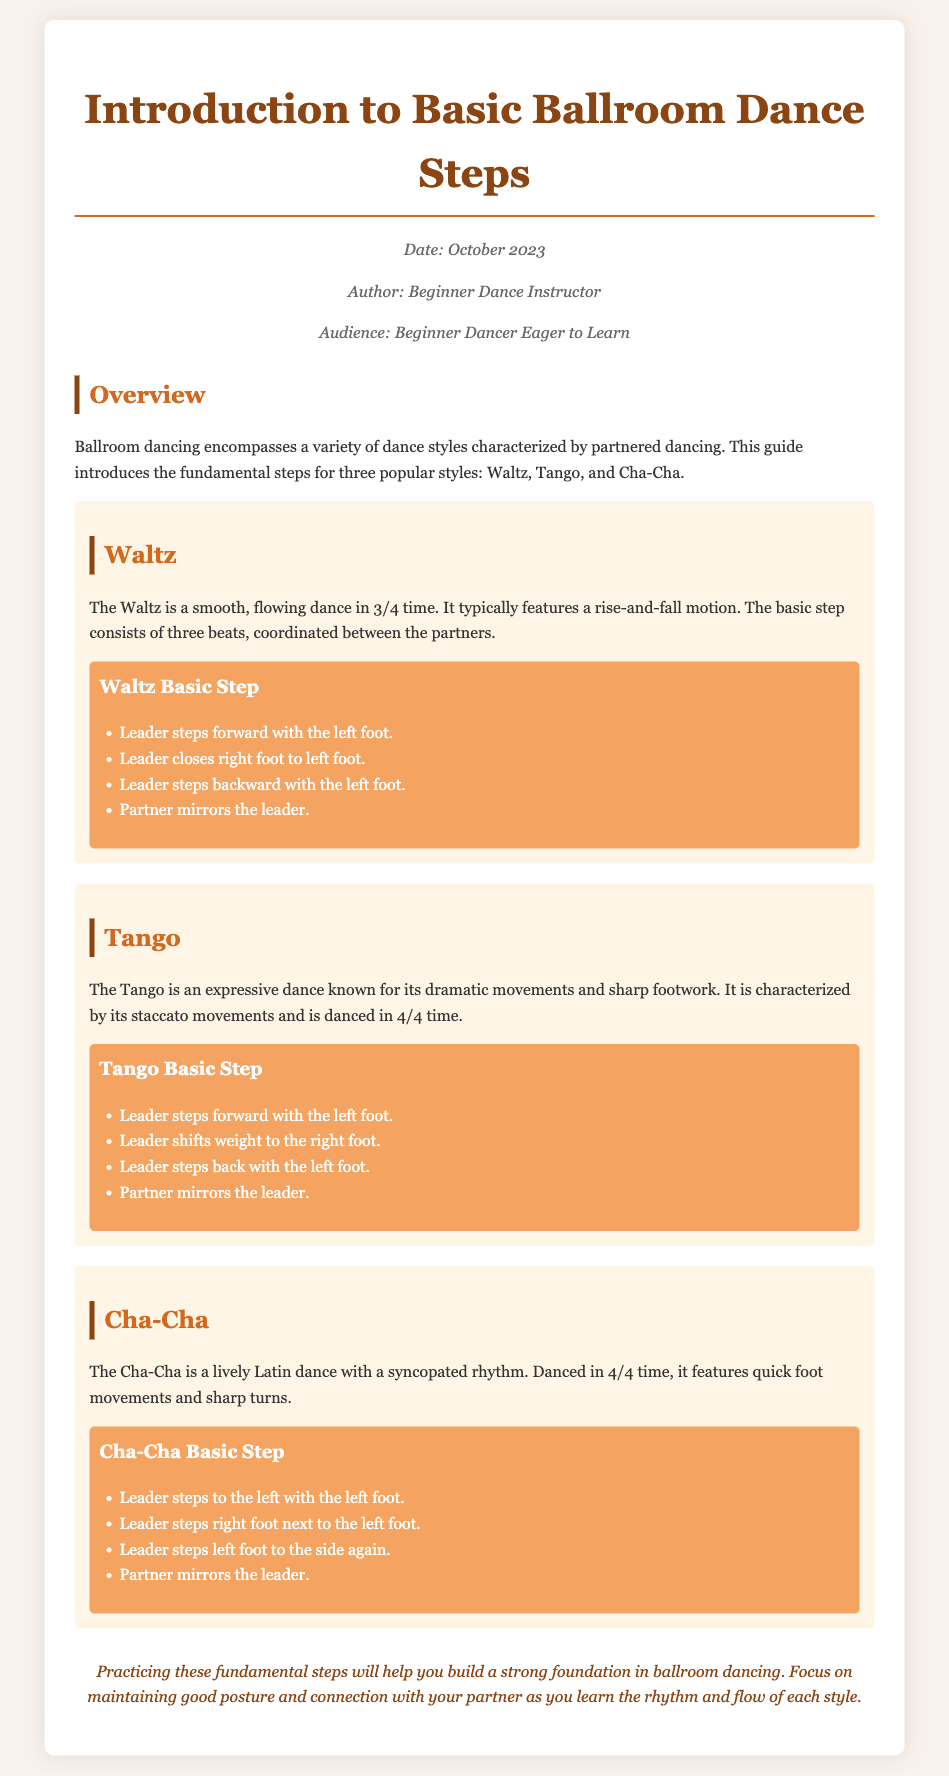What is the title of the document? The title is provided prominently at the beginning of the document.
Answer: Introduction to Basic Ballroom Dance Steps Who is the author of this memo? The author is identified in the meta section of the document.
Answer: Beginner Dance Instructor What is the time signature of the Waltz? The time signature associated with the Waltz is mentioned in the description of the dance style.
Answer: 3/4 How many steps are included in the basic step of Cha-Cha? The document lists the steps for Cha-Cha, and we need to count them.
Answer: 4 What is the primary characteristic of the Tango? The document describes the Tango and mentions its key features.
Answer: Dramatic movements In which section does the conclusion appear? The conclusion is indicated as a distinct section towards the end of the document.
Answer: Conclusion Which dance style features a rise-and-fall motion? The dance style pertaining to a rise-and-fall motion is described in relation to one specific type.
Answer: Waltz What is the main focus when practicing the fundamental steps? The conclusion outlines key aspects to focus on during practice.
Answer: Good posture and connection with your partner 